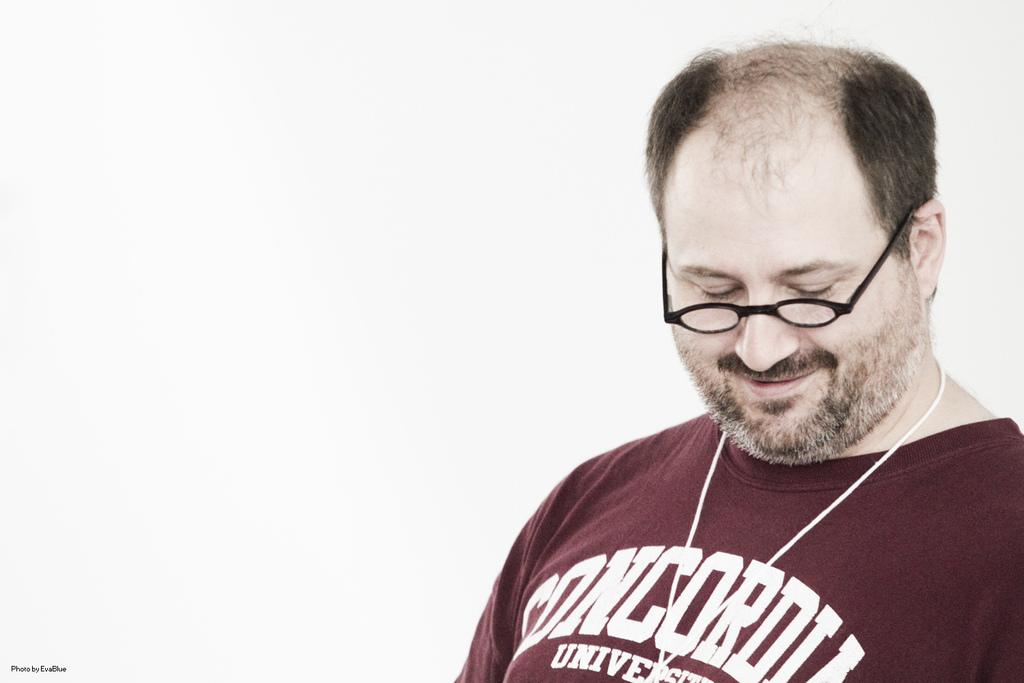What is the main subject of the image? The main subject of the image is a man. What is the man doing in the image? The man is standing in the image. What accessory is the man wearing in the image? The man is wearing spectacles in the image. How many girls are present in the image? There are no girls present in the image; it features a man. What type of screw can be seen on the man's shirt in the image? There is no screw visible on the man's shirt in the image. 